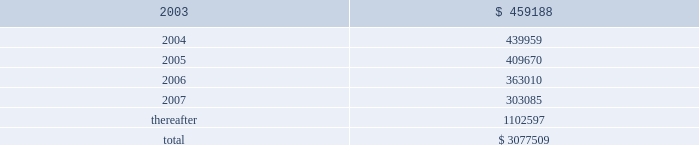American tower corporation and subsidiaries notes to consolidated financial statements 2014 ( continued ) customer leases 2014the company 2019s lease agreements with its customers vary depending upon the industry .
Television and radio broadcasters prefer long-term leases , while wireless communications providers favor leases in the range of five to ten years .
Most leases contain renewal options .
Escalation clauses present in operating leases , excluding those tied to cpi , are straight-lined over the term of the lease .
Future minimum rental receipts expected from customers under noncancelable operating lease agreements in effect at december 31 , 2002 are as follows ( in thousands ) : year ending december 31 .
Acquisition commitments 2014as of december 31 , 2002 , the company was party to an agreement relating to the acquisition of tower assets from a third party for an estimated aggregate purchase price of approximately $ 74.0 million .
The company may pursue the acquisitions of other properties and businesses in new and existing locations , although there are no definitive material agreements with respect thereto .
Build-to-suit agreements 2014as of december 31 , 2002 , the company was party to various arrangements relating to the construction of tower sites under existing build-to-suit agreements .
Under the terms of the agreements , the company is obligated to construct up to 1000 towers over a five year period which includes 650 towers in mexico and 350 towers in brazil over the next three years .
The company is in the process of renegotiating several of these agreements to reduce its overall commitment ; however , there can be no assurance that it will be successful in doing so .
Atc separation 2014the company was a wholly owned subsidiary of american radio systems corporation ( american radio ) until consummation of the spin-off of the company from american radio on june 4 , 1998 ( the atc separation ) .
On june 4 , 1998 , the merger of american radio and a subsidiary of cbs corporation ( cbs ) was consummated .
As a result of the merger , all of the outstanding shares of the company 2019s common stock owned by american radio were distributed or reserved for distribution to american radio stockholders , and the company ceased to be a subsidiary of , or to be otherwise affiliated with , american radio .
Furthermore , from that day forward the company began operating as an independent publicly traded company .
In connection with the atc separation , the company agreed to reimburse cbs for any tax liabilities incurred by american radio as a result of the transaction .
Upon completion of the final american radio tax returns , the amount of these tax liabilities was determined and paid by the company .
The company continues to be obligated under a tax indemnification agreement with cbs , however , until june 30 , 2003 , subject to the extension of federal and applicable state statutes of limitations .
The company is currently aware that the internal revenue service ( irs ) is in the process of auditing certain tax returns filed by cbs and its predecessors , including those that relate to american radio and the atc separation transaction .
In the event that the irs imposes additional tax liabilities on american radio relating to the atc separation , the company would be obligated to reimburse cbs for such liabilities .
The company cannot currently anticipate or estimate the potential additional tax liabilities , if any , that may be imposed by the irs , however , such amounts could be material to the company 2019s consolidated financial position and results of operations .
The company is not aware of any material obligations relating to this tax indemnity as of december 31 , 2002 .
Accordingly , no amounts have been provided for in the consolidated financial statements relating to this indemnification. .
What portion of future minimum rental receipts is expected to be collected within the next 24 months? 
Computations: ((459188 + 439959) / 3077509)
Answer: 0.29217. 